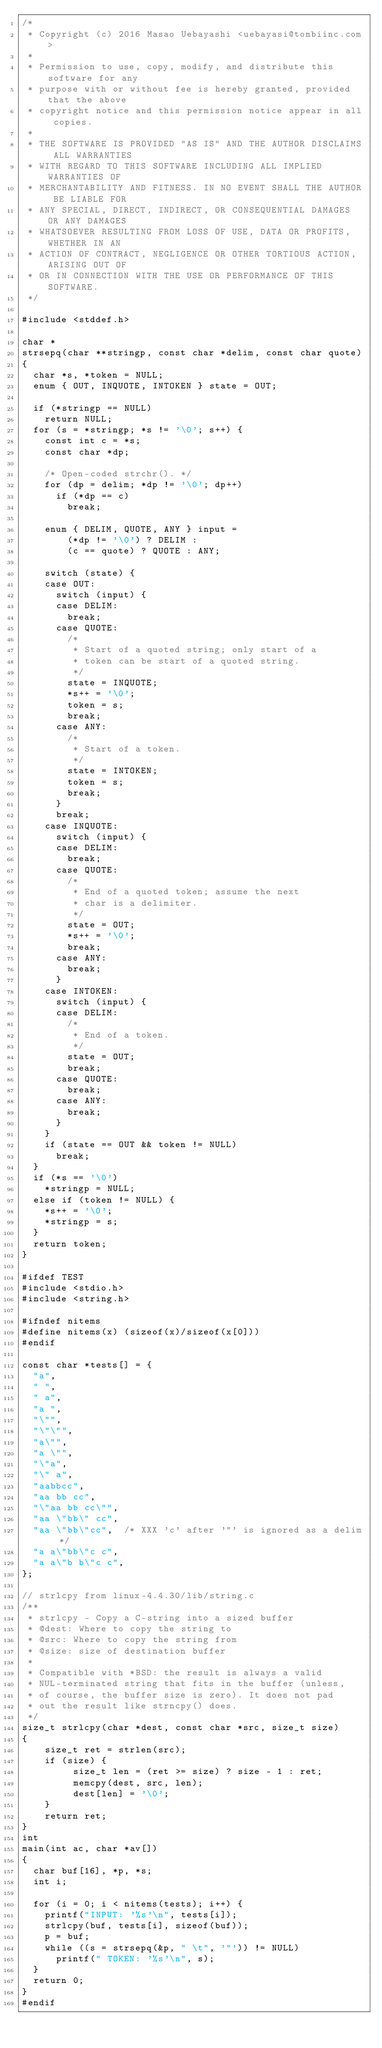<code> <loc_0><loc_0><loc_500><loc_500><_C_>/*
 * Copyright (c) 2016 Masao Uebayashi <uebayasi@tombiinc.com>
 *
 * Permission to use, copy, modify, and distribute this software for any
 * purpose with or without fee is hereby granted, provided that the above
 * copyright notice and this permission notice appear in all copies.
 *
 * THE SOFTWARE IS PROVIDED "AS IS" AND THE AUTHOR DISCLAIMS ALL WARRANTIES
 * WITH REGARD TO THIS SOFTWARE INCLUDING ALL IMPLIED WARRANTIES OF
 * MERCHANTABILITY AND FITNESS. IN NO EVENT SHALL THE AUTHOR BE LIABLE FOR
 * ANY SPECIAL, DIRECT, INDIRECT, OR CONSEQUENTIAL DAMAGES OR ANY DAMAGES
 * WHATSOEVER RESULTING FROM LOSS OF USE, DATA OR PROFITS, WHETHER IN AN
 * ACTION OF CONTRACT, NEGLIGENCE OR OTHER TORTIOUS ACTION, ARISING OUT OF
 * OR IN CONNECTION WITH THE USE OR PERFORMANCE OF THIS SOFTWARE.
 */

#include <stddef.h>

char *
strsepq(char **stringp, const char *delim, const char quote)
{
	char *s, *token = NULL;
	enum { OUT, INQUOTE, INTOKEN } state = OUT;

	if (*stringp == NULL)
		return NULL;
	for (s = *stringp; *s != '\0'; s++) {
		const int c = *s;
		const char *dp;

		/* Open-coded strchr(). */
		for (dp = delim; *dp != '\0'; dp++)
			if (*dp == c)
				break;

		enum { DELIM, QUOTE, ANY } input =
		    (*dp != '\0') ? DELIM :
		    (c == quote) ? QUOTE : ANY;

		switch (state) {
		case OUT:
			switch (input) {
			case DELIM:
				break;
			case QUOTE:
				/*
				 * Start of a quoted string; only start of a
				 * token can be start of a quoted string.
				 */
				state = INQUOTE;
				*s++ = '\0';
				token = s;
				break;
			case ANY:
				/*
				 * Start of a token.
				 */
				state = INTOKEN;
				token = s;
				break;
			}
			break;
		case INQUOTE:
			switch (input) {
			case DELIM:
				break;
			case QUOTE:
				/*
				 * End of a quoted token; assume the next
				 * char is a delimiter.
				 */
				state = OUT;
				*s++ = '\0';
				break;
			case ANY:
				break;
			}
		case INTOKEN:
			switch (input) {
			case DELIM:
				/*
				 * End of a token.
				 */
				state = OUT;
				break;
			case QUOTE:
				break;
			case ANY:
				break;
			}
		}
		if (state == OUT && token != NULL)
			break;
	}
	if (*s == '\0')
		*stringp = NULL;
	else if (token != NULL) {
		*s++ = '\0';
		*stringp = s;
	}
	return token;
}

#ifdef TEST
#include <stdio.h>
#include <string.h>

#ifndef nitems
#define nitems(x) (sizeof(x)/sizeof(x[0]))
#endif

const char *tests[] = {
	"a",
	" ",
	" a",
	"a ",
	"\"",
	"\"\"",
	"a\"",
	"a \"",
	"\"a",
	"\" a",
	"aabbcc",
	"aa bb cc",
	"\"aa bb cc\"",
	"aa \"bb\" cc",
	"aa \"bb\"cc",  /* XXX 'c' after '"' is ignored as a delim */
	"a a\"bb\"c c",
	"a a\"b b\"c c",
};

// strlcpy from linux-4.4.30/lib/string.c
/**                                                                              
 * strlcpy - Copy a C-string into a sized buffer                                 
 * @dest: Where to copy the string to                                            
 * @src: Where to copy the string from                                           
 * @size: size of destination buffer                                             
 *                                                                               
 * Compatible with *BSD: the result is always a valid                            
 * NUL-terminated string that fits in the buffer (unless,                        
 * of course, the buffer size is zero). It does not pad                          
 * out the result like strncpy() does.                                           
 */                                                                              
size_t strlcpy(char *dest, const char *src, size_t size)                         
{                                                                                
    size_t ret = strlen(src);                                                    
    if (size) {                                                                  
         size_t len = (ret >= size) ? size - 1 : ret;                             
         memcpy(dest, src, len);                                                  
         dest[len] = '\0';                                                        
    }                                                                            
    return ret;                                                                  
}  
int
main(int ac, char *av[])
{
	char buf[16], *p, *s;
	int i;

	for (i = 0; i < nitems(tests); i++) {
		printf("INPUT: '%s'\n", tests[i]);
		strlcpy(buf, tests[i], sizeof(buf));
		p = buf;
		while ((s = strsepq(&p, " \t", '"')) != NULL)
			printf(" TOKEN: '%s'\n", s);
	}
	return 0;
}
#endif
</code> 